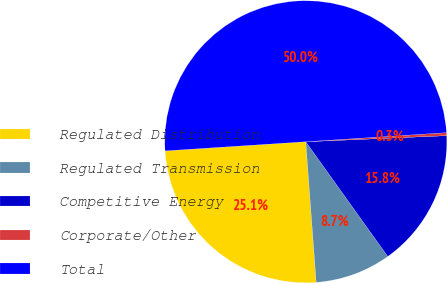Convert chart to OTSL. <chart><loc_0><loc_0><loc_500><loc_500><pie_chart><fcel>Regulated Distribution<fcel>Regulated Transmission<fcel>Competitive Energy<fcel>Corporate/Other<fcel>Total<nl><fcel>25.14%<fcel>8.7%<fcel>15.81%<fcel>0.34%<fcel>50.0%<nl></chart> 